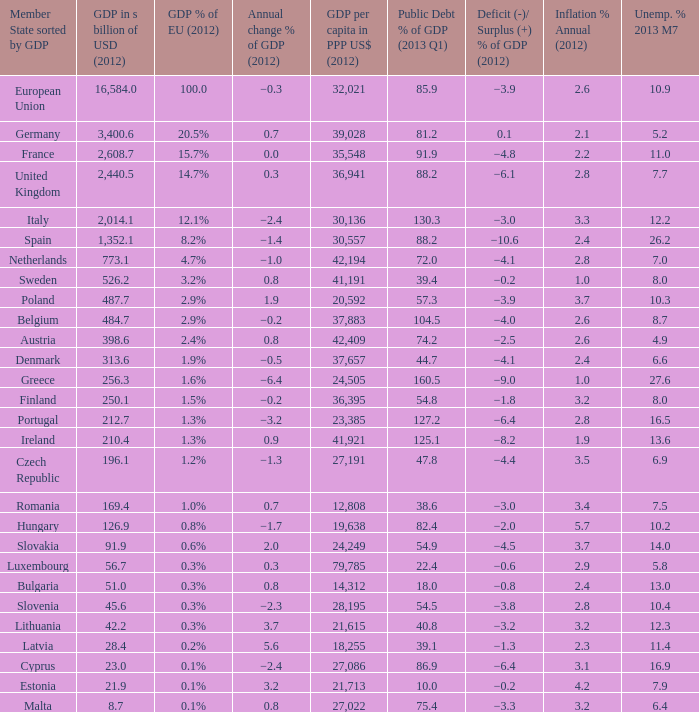What is the gdp percentage of the european union in 2012 for the nation with a 2012 gdp worth 25 1.6%. 